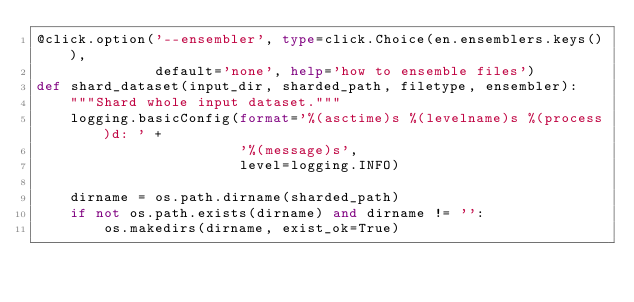<code> <loc_0><loc_0><loc_500><loc_500><_Python_>@click.option('--ensembler', type=click.Choice(en.ensemblers.keys()),
              default='none', help='how to ensemble files')
def shard_dataset(input_dir, sharded_path, filetype, ensembler):
    """Shard whole input dataset."""
    logging.basicConfig(format='%(asctime)s %(levelname)s %(process)d: ' +
                        '%(message)s',
                        level=logging.INFO)

    dirname = os.path.dirname(sharded_path)
    if not os.path.exists(dirname) and dirname != '':
        os.makedirs(dirname, exist_ok=True)
</code> 